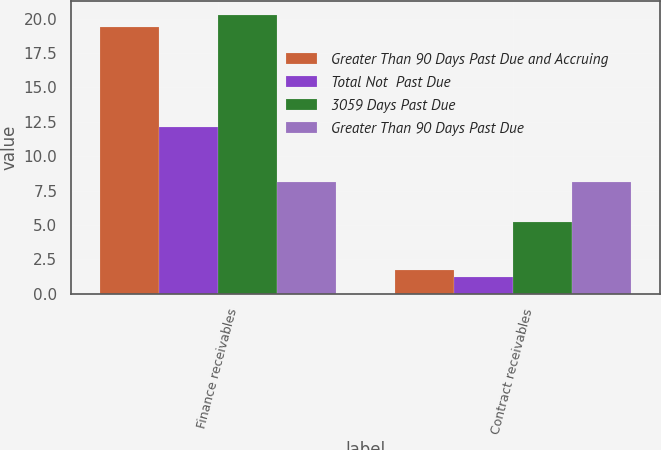<chart> <loc_0><loc_0><loc_500><loc_500><stacked_bar_chart><ecel><fcel>Finance receivables<fcel>Contract receivables<nl><fcel>Greater Than 90 Days Past Due and Accruing<fcel>19.4<fcel>1.7<nl><fcel>Total Not  Past Due<fcel>12.1<fcel>1.2<nl><fcel>3059 Days Past Due<fcel>20.3<fcel>5.2<nl><fcel>Greater Than 90 Days Past Due<fcel>8.1<fcel>8.1<nl></chart> 